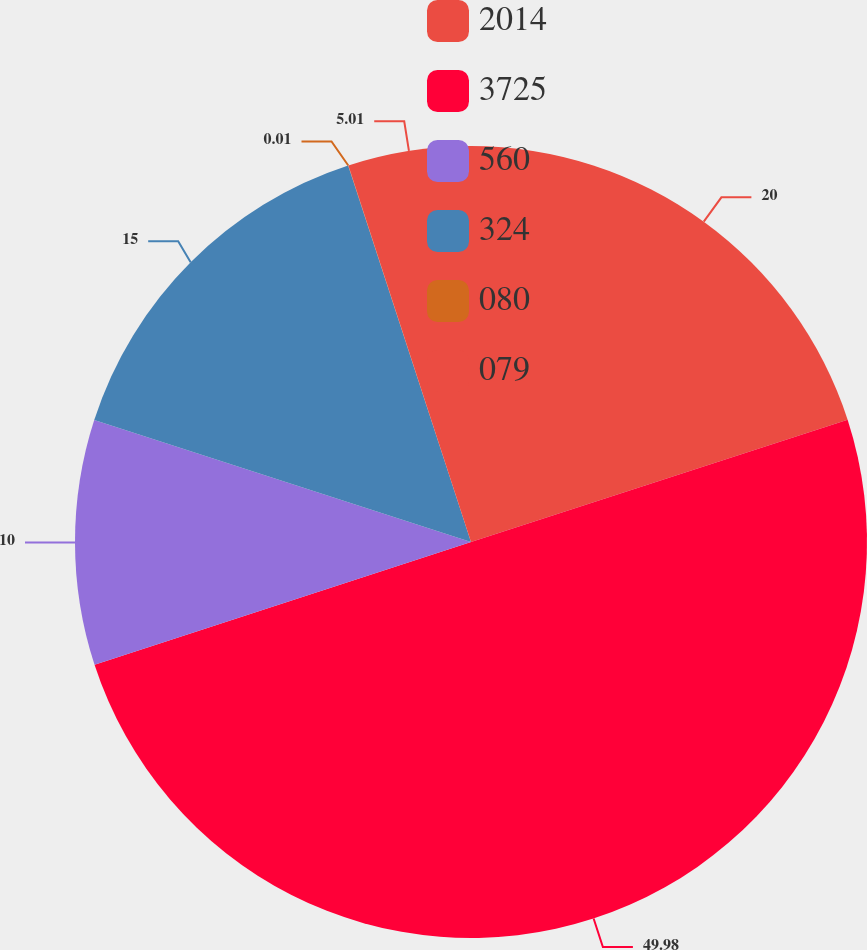Convert chart to OTSL. <chart><loc_0><loc_0><loc_500><loc_500><pie_chart><fcel>2014<fcel>3725<fcel>560<fcel>324<fcel>080<fcel>079<nl><fcel>20.0%<fcel>49.98%<fcel>10.0%<fcel>15.0%<fcel>0.01%<fcel>5.01%<nl></chart> 